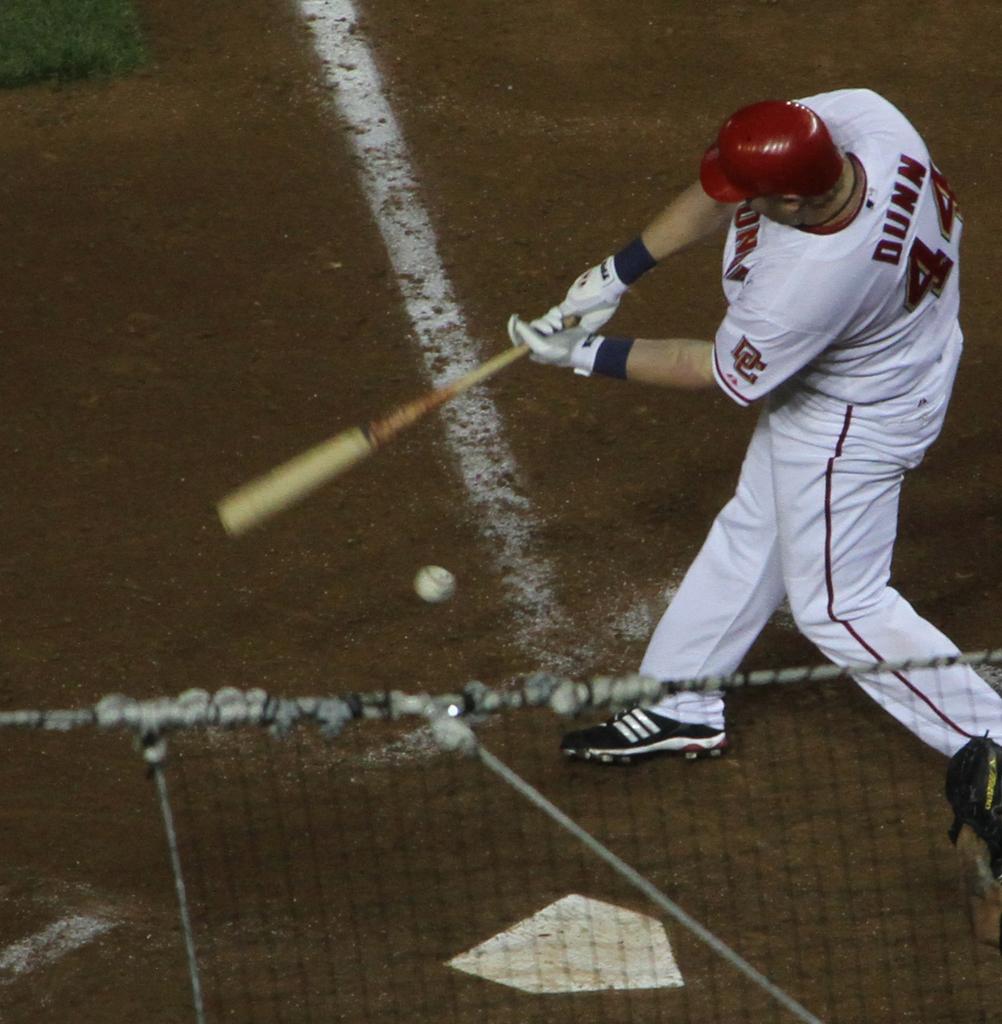What is 44's last name?
Give a very brief answer. Dunn. 